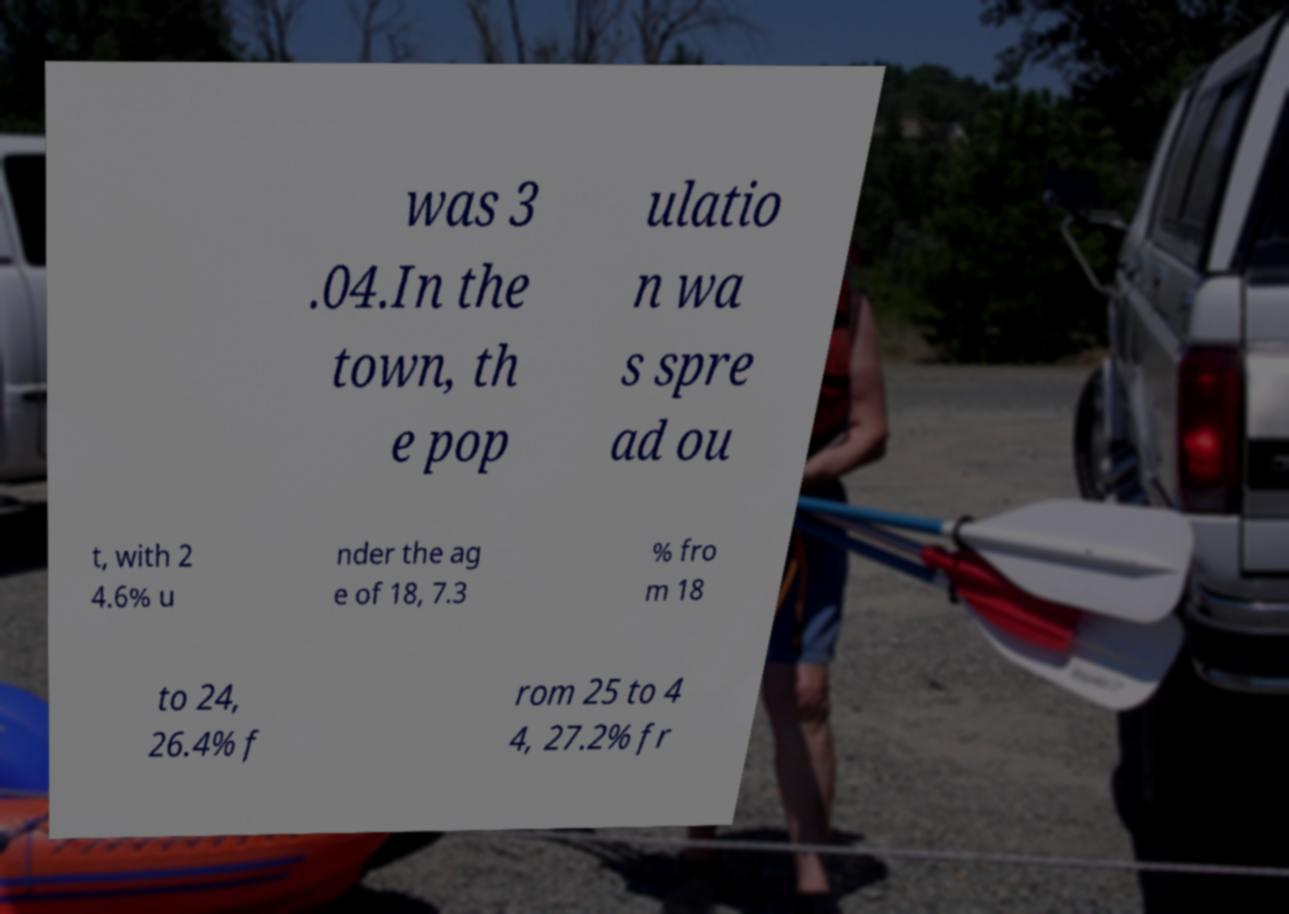Could you assist in decoding the text presented in this image and type it out clearly? was 3 .04.In the town, th e pop ulatio n wa s spre ad ou t, with 2 4.6% u nder the ag e of 18, 7.3 % fro m 18 to 24, 26.4% f rom 25 to 4 4, 27.2% fr 